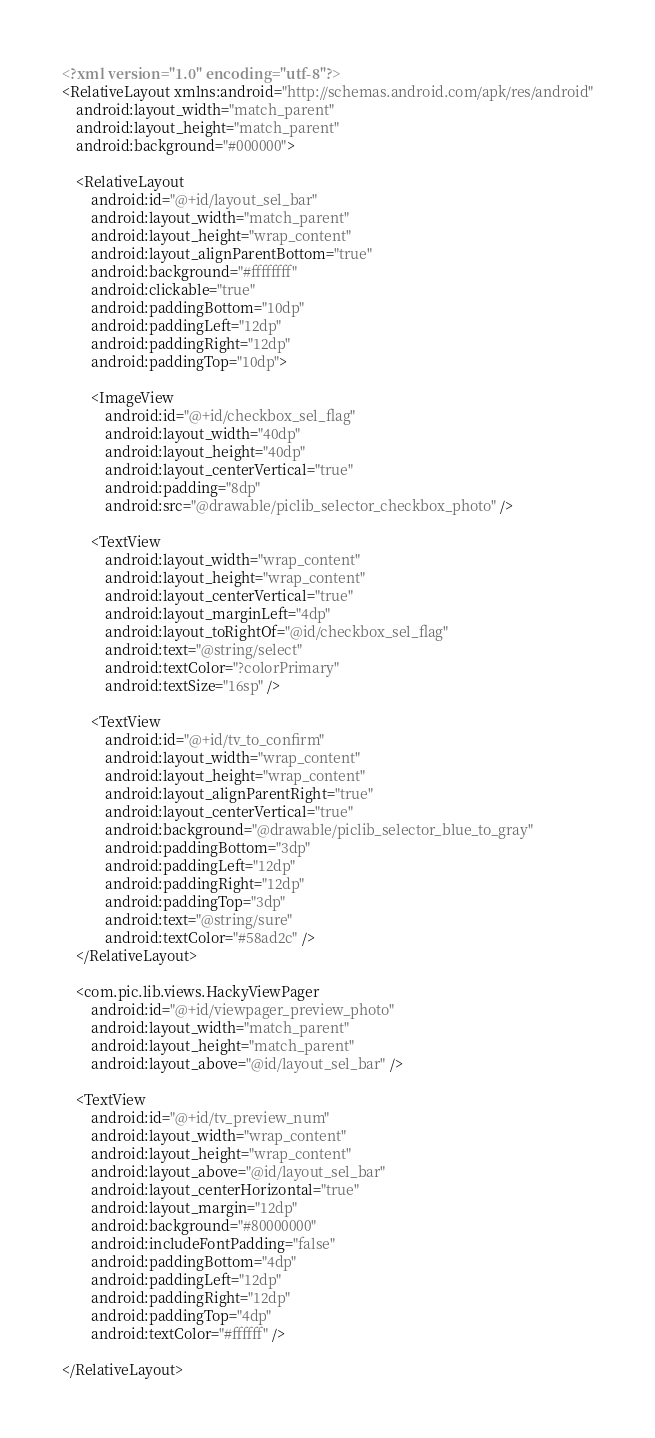<code> <loc_0><loc_0><loc_500><loc_500><_XML_><?xml version="1.0" encoding="utf-8"?>
<RelativeLayout xmlns:android="http://schemas.android.com/apk/res/android"
    android:layout_width="match_parent"
    android:layout_height="match_parent"
    android:background="#000000">

    <RelativeLayout
        android:id="@+id/layout_sel_bar"
        android:layout_width="match_parent"
        android:layout_height="wrap_content"
        android:layout_alignParentBottom="true"
        android:background="#ffffffff"
        android:clickable="true"
        android:paddingBottom="10dp"
        android:paddingLeft="12dp"
        android:paddingRight="12dp"
        android:paddingTop="10dp">

        <ImageView
            android:id="@+id/checkbox_sel_flag"
            android:layout_width="40dp"
            android:layout_height="40dp"
            android:layout_centerVertical="true"
            android:padding="8dp"
            android:src="@drawable/piclib_selector_checkbox_photo" />

        <TextView
            android:layout_width="wrap_content"
            android:layout_height="wrap_content"
            android:layout_centerVertical="true"
            android:layout_marginLeft="4dp"
            android:layout_toRightOf="@id/checkbox_sel_flag"
            android:text="@string/select"
            android:textColor="?colorPrimary"
            android:textSize="16sp" />

        <TextView
            android:id="@+id/tv_to_confirm"
            android:layout_width="wrap_content"
            android:layout_height="wrap_content"
            android:layout_alignParentRight="true"
            android:layout_centerVertical="true"
            android:background="@drawable/piclib_selector_blue_to_gray"
            android:paddingBottom="3dp"
            android:paddingLeft="12dp"
            android:paddingRight="12dp"
            android:paddingTop="3dp"
            android:text="@string/sure"
            android:textColor="#58ad2c" />
    </RelativeLayout>

    <com.pic.lib.views.HackyViewPager
        android:id="@+id/viewpager_preview_photo"
        android:layout_width="match_parent"
        android:layout_height="match_parent"
        android:layout_above="@id/layout_sel_bar" />

    <TextView
        android:id="@+id/tv_preview_num"
        android:layout_width="wrap_content"
        android:layout_height="wrap_content"
        android:layout_above="@id/layout_sel_bar"
        android:layout_centerHorizontal="true"
        android:layout_margin="12dp"
        android:background="#80000000"
        android:includeFontPadding="false"
        android:paddingBottom="4dp"
        android:paddingLeft="12dp"
        android:paddingRight="12dp"
        android:paddingTop="4dp"
        android:textColor="#ffffff" />

</RelativeLayout>
</code> 